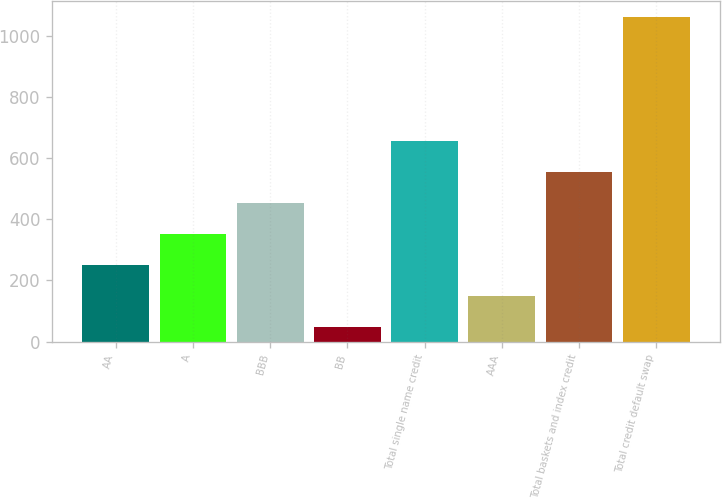Convert chart. <chart><loc_0><loc_0><loc_500><loc_500><bar_chart><fcel>AA<fcel>A<fcel>BBB<fcel>BB<fcel>Total single name credit<fcel>AAA<fcel>Total baskets and index credit<fcel>Total credit default swap<nl><fcel>250.68<fcel>352.02<fcel>453.36<fcel>48<fcel>656.04<fcel>149.34<fcel>554.7<fcel>1061.4<nl></chart> 